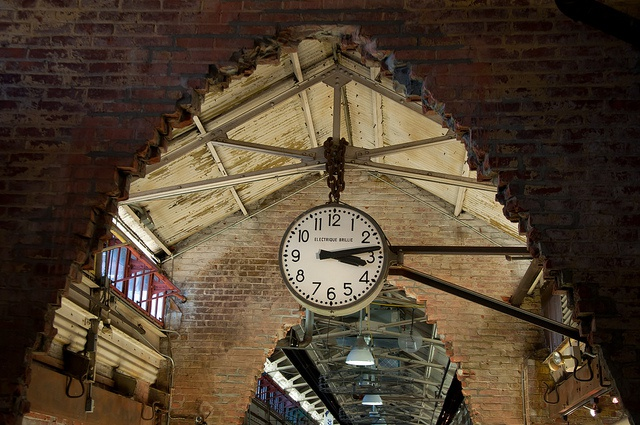Describe the objects in this image and their specific colors. I can see a clock in black, darkgray, lightgray, and tan tones in this image. 